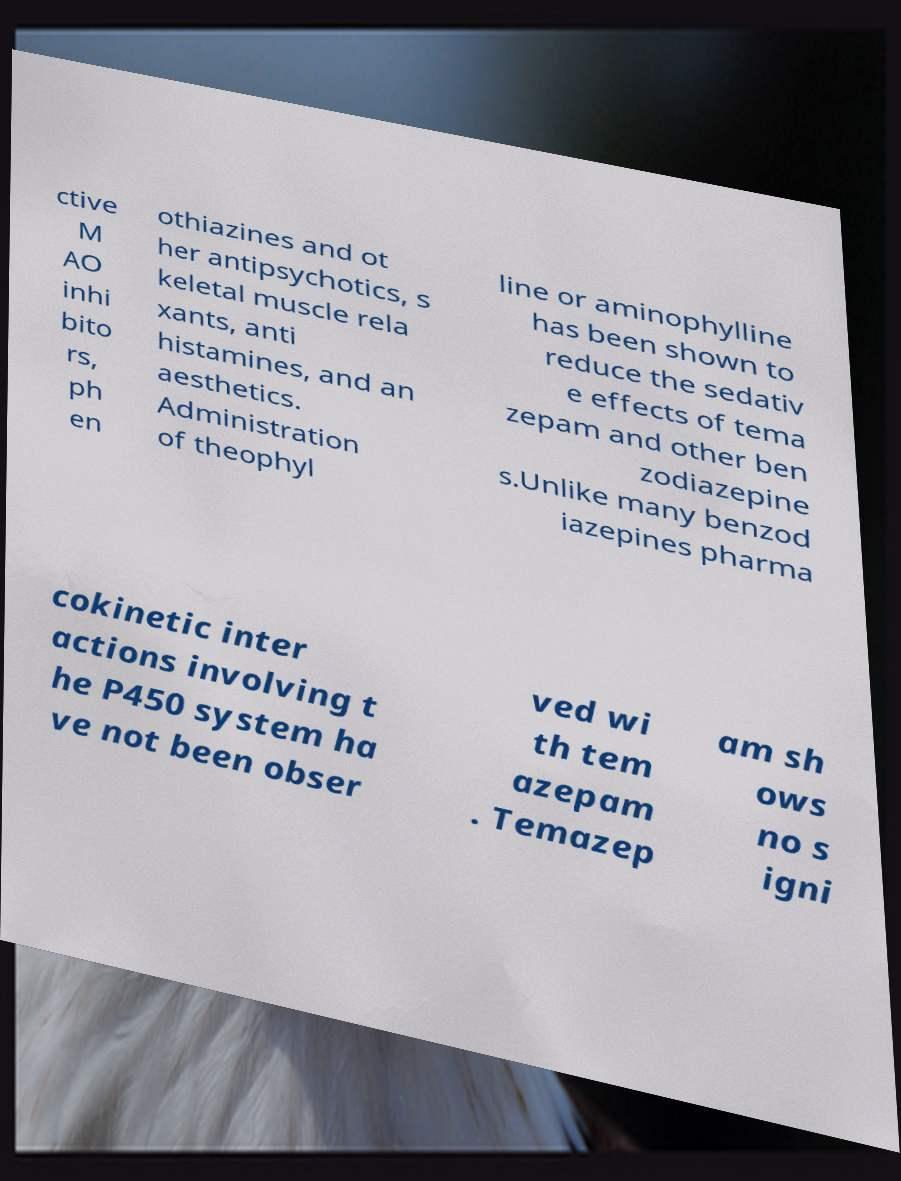There's text embedded in this image that I need extracted. Can you transcribe it verbatim? ctive M AO inhi bito rs, ph en othiazines and ot her antipsychotics, s keletal muscle rela xants, anti histamines, and an aesthetics. Administration of theophyl line or aminophylline has been shown to reduce the sedativ e effects of tema zepam and other ben zodiazepine s.Unlike many benzod iazepines pharma cokinetic inter actions involving t he P450 system ha ve not been obser ved wi th tem azepam . Temazep am sh ows no s igni 